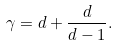<formula> <loc_0><loc_0><loc_500><loc_500>\gamma = d + \frac { d } { d - 1 } .</formula> 